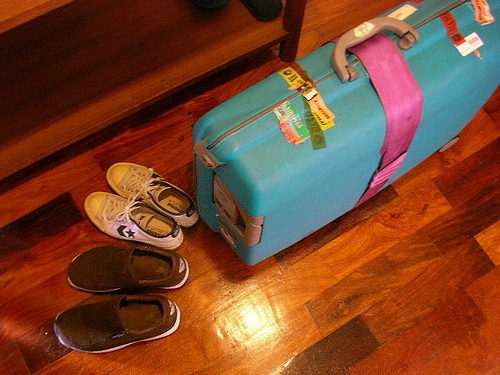Describe the objects in this image and their specific colors. I can see a suitcase in red, teal, and violet tones in this image. 